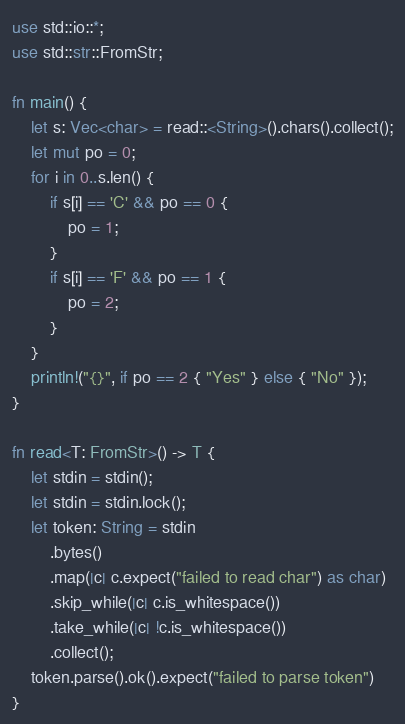<code> <loc_0><loc_0><loc_500><loc_500><_Rust_>use std::io::*;
use std::str::FromStr;

fn main() {
    let s: Vec<char> = read::<String>().chars().collect();
    let mut po = 0;
    for i in 0..s.len() {
        if s[i] == 'C' && po == 0 {
            po = 1;
        }
        if s[i] == 'F' && po == 1 {
            po = 2;
        }
    }
    println!("{}", if po == 2 { "Yes" } else { "No" });
}

fn read<T: FromStr>() -> T {
    let stdin = stdin();
    let stdin = stdin.lock();
    let token: String = stdin
        .bytes()
        .map(|c| c.expect("failed to read char") as char)
        .skip_while(|c| c.is_whitespace())
        .take_while(|c| !c.is_whitespace())
        .collect();
    token.parse().ok().expect("failed to parse token")
}
</code> 